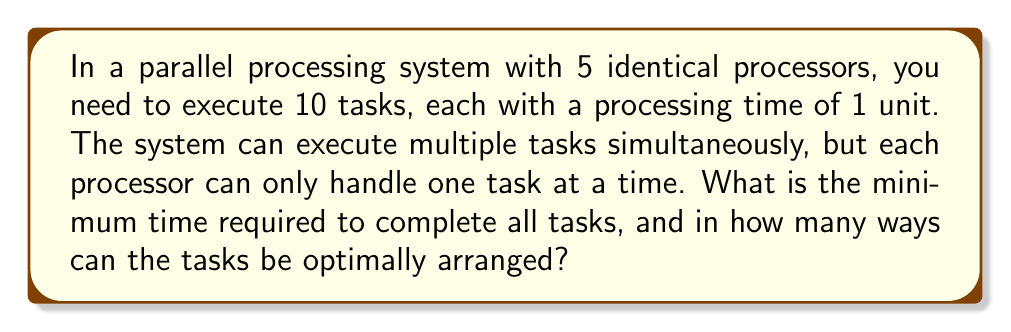Can you answer this question? Let's approach this step-by-step:

1) First, we need to determine the minimum time required to complete all tasks:
   - Total processing time of all tasks: $10 \times 1 = 10$ units
   - Number of processors: 5
   - Minimum time = $\left\lceil\frac{\text{Total processing time}}{\text{Number of processors}}\right\rceil = \left\lceil\frac{10}{5}\right\rceil = 2$ units

2) Now, we need to calculate the number of ways to arrange the tasks optimally:
   - In the optimal arrangement, all 5 processors will be busy for the first time unit, and 5 processors will be busy for the second time unit.
   - This is equivalent to distributing 10 distinct tasks into 2 groups of 5 tasks each.
   - This can be modeled as a combination problem: $\binom{10}{5}$

3) Calculate $\binom{10}{5}$:
   $$\binom{10}{5} = \frac{10!}{5!(10-5)!} = \frac{10!}{5!5!}$$
   $$= \frac{10 \times 9 \times 8 \times 7 \times 6}{5 \times 4 \times 3 \times 2 \times 1} = 252$$

Therefore, there are 252 ways to optimally arrange the tasks.
Answer: 2 time units; 252 ways 